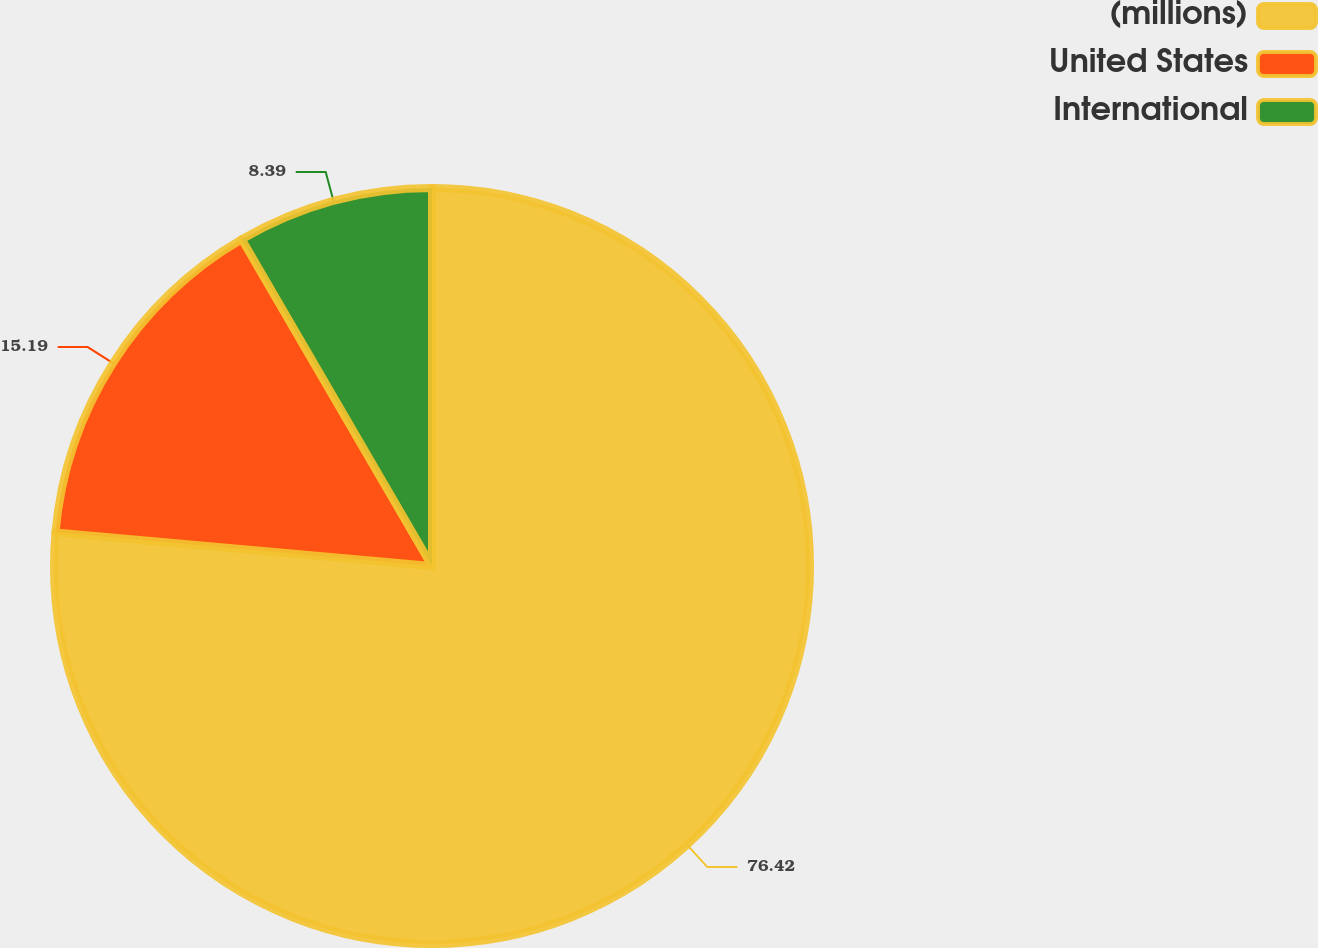Convert chart. <chart><loc_0><loc_0><loc_500><loc_500><pie_chart><fcel>(millions)<fcel>United States<fcel>International<nl><fcel>76.41%<fcel>15.19%<fcel>8.39%<nl></chart> 